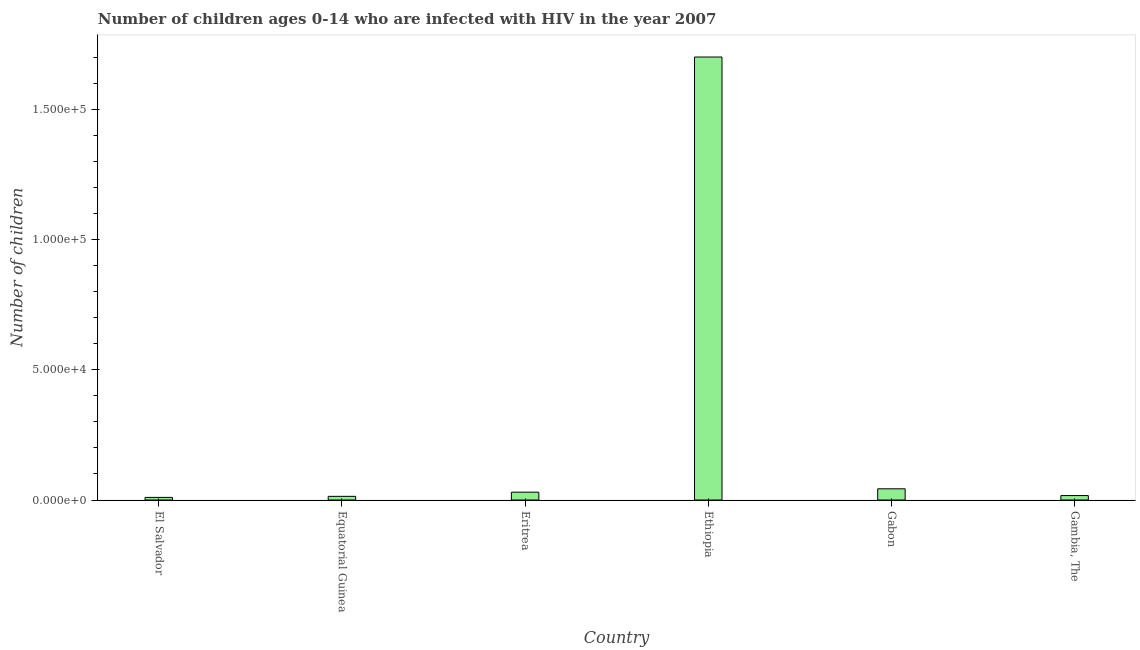What is the title of the graph?
Offer a terse response. Number of children ages 0-14 who are infected with HIV in the year 2007. What is the label or title of the X-axis?
Provide a succinct answer. Country. What is the label or title of the Y-axis?
Offer a very short reply. Number of children. What is the number of children living with hiv in Gambia, The?
Offer a terse response. 1700. In which country was the number of children living with hiv maximum?
Provide a short and direct response. Ethiopia. In which country was the number of children living with hiv minimum?
Give a very brief answer. El Salvador. What is the sum of the number of children living with hiv?
Offer a terse response. 1.81e+05. What is the difference between the number of children living with hiv in El Salvador and Equatorial Guinea?
Your response must be concise. -400. What is the average number of children living with hiv per country?
Your answer should be very brief. 3.02e+04. What is the median number of children living with hiv?
Give a very brief answer. 2350. What is the ratio of the number of children living with hiv in El Salvador to that in Gabon?
Your answer should be compact. 0.23. What is the difference between the highest and the second highest number of children living with hiv?
Provide a short and direct response. 1.66e+05. What is the difference between the highest and the lowest number of children living with hiv?
Give a very brief answer. 1.69e+05. How many bars are there?
Keep it short and to the point. 6. Are all the bars in the graph horizontal?
Offer a terse response. No. How many countries are there in the graph?
Your answer should be very brief. 6. What is the difference between two consecutive major ticks on the Y-axis?
Your answer should be compact. 5.00e+04. What is the Number of children in Equatorial Guinea?
Ensure brevity in your answer.  1400. What is the Number of children of Eritrea?
Provide a succinct answer. 3000. What is the Number of children in Ethiopia?
Provide a short and direct response. 1.70e+05. What is the Number of children of Gabon?
Your response must be concise. 4300. What is the Number of children in Gambia, The?
Your response must be concise. 1700. What is the difference between the Number of children in El Salvador and Equatorial Guinea?
Provide a short and direct response. -400. What is the difference between the Number of children in El Salvador and Eritrea?
Your answer should be compact. -2000. What is the difference between the Number of children in El Salvador and Ethiopia?
Your answer should be very brief. -1.69e+05. What is the difference between the Number of children in El Salvador and Gabon?
Make the answer very short. -3300. What is the difference between the Number of children in El Salvador and Gambia, The?
Keep it short and to the point. -700. What is the difference between the Number of children in Equatorial Guinea and Eritrea?
Give a very brief answer. -1600. What is the difference between the Number of children in Equatorial Guinea and Ethiopia?
Offer a very short reply. -1.69e+05. What is the difference between the Number of children in Equatorial Guinea and Gabon?
Ensure brevity in your answer.  -2900. What is the difference between the Number of children in Equatorial Guinea and Gambia, The?
Provide a short and direct response. -300. What is the difference between the Number of children in Eritrea and Ethiopia?
Offer a very short reply. -1.67e+05. What is the difference between the Number of children in Eritrea and Gabon?
Provide a succinct answer. -1300. What is the difference between the Number of children in Eritrea and Gambia, The?
Offer a very short reply. 1300. What is the difference between the Number of children in Ethiopia and Gabon?
Provide a short and direct response. 1.66e+05. What is the difference between the Number of children in Ethiopia and Gambia, The?
Ensure brevity in your answer.  1.68e+05. What is the difference between the Number of children in Gabon and Gambia, The?
Offer a very short reply. 2600. What is the ratio of the Number of children in El Salvador to that in Equatorial Guinea?
Keep it short and to the point. 0.71. What is the ratio of the Number of children in El Salvador to that in Eritrea?
Offer a terse response. 0.33. What is the ratio of the Number of children in El Salvador to that in Ethiopia?
Make the answer very short. 0.01. What is the ratio of the Number of children in El Salvador to that in Gabon?
Your response must be concise. 0.23. What is the ratio of the Number of children in El Salvador to that in Gambia, The?
Provide a succinct answer. 0.59. What is the ratio of the Number of children in Equatorial Guinea to that in Eritrea?
Give a very brief answer. 0.47. What is the ratio of the Number of children in Equatorial Guinea to that in Ethiopia?
Offer a terse response. 0.01. What is the ratio of the Number of children in Equatorial Guinea to that in Gabon?
Make the answer very short. 0.33. What is the ratio of the Number of children in Equatorial Guinea to that in Gambia, The?
Make the answer very short. 0.82. What is the ratio of the Number of children in Eritrea to that in Ethiopia?
Make the answer very short. 0.02. What is the ratio of the Number of children in Eritrea to that in Gabon?
Give a very brief answer. 0.7. What is the ratio of the Number of children in Eritrea to that in Gambia, The?
Ensure brevity in your answer.  1.76. What is the ratio of the Number of children in Ethiopia to that in Gabon?
Your response must be concise. 39.53. What is the ratio of the Number of children in Ethiopia to that in Gambia, The?
Keep it short and to the point. 100. What is the ratio of the Number of children in Gabon to that in Gambia, The?
Provide a short and direct response. 2.53. 